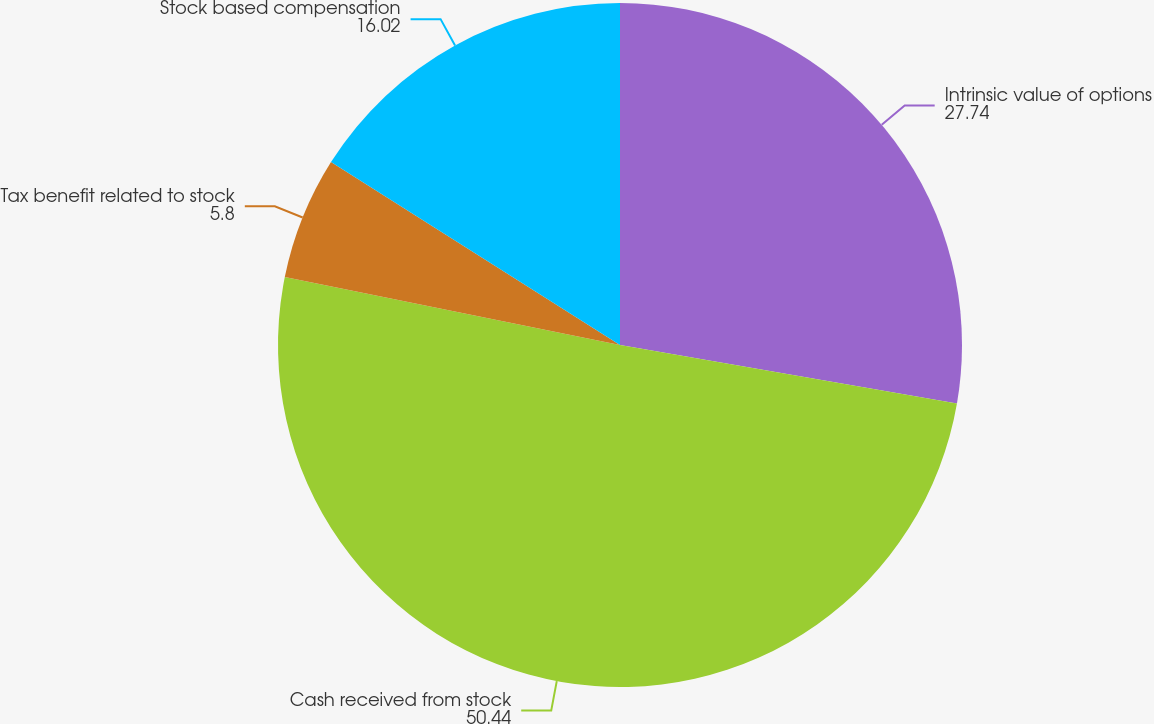Convert chart to OTSL. <chart><loc_0><loc_0><loc_500><loc_500><pie_chart><fcel>Intrinsic value of options<fcel>Cash received from stock<fcel>Tax benefit related to stock<fcel>Stock based compensation<nl><fcel>27.74%<fcel>50.44%<fcel>5.8%<fcel>16.02%<nl></chart> 